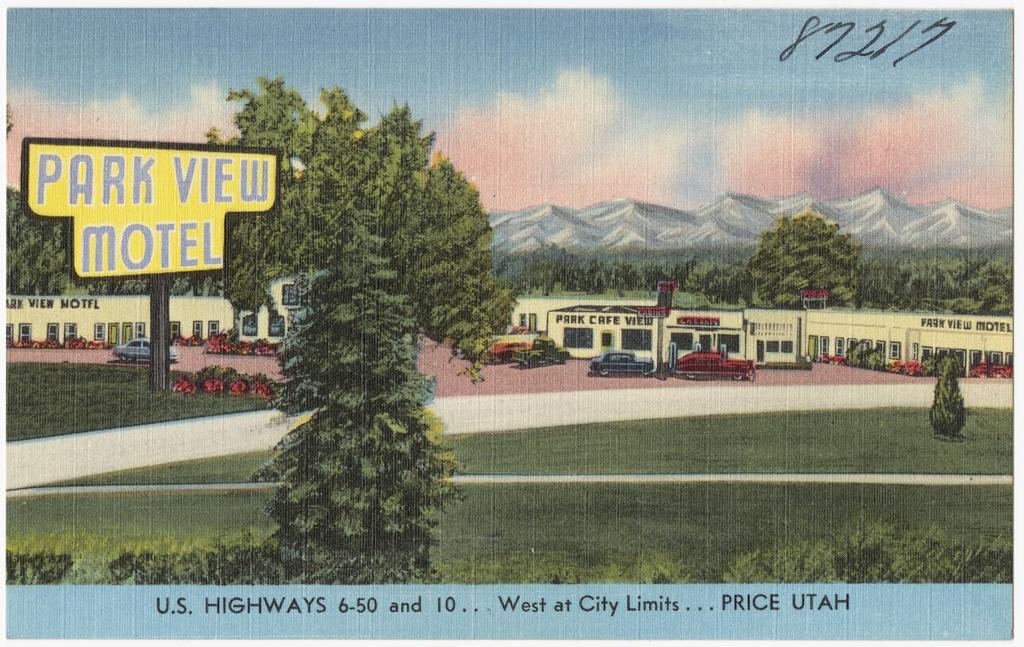Please provide a concise description of this image. In this image there is a painting of trees, cars, buildings, mountains and there is grass on the ground and there is a pole, board with some text and the sky is cloudy. 